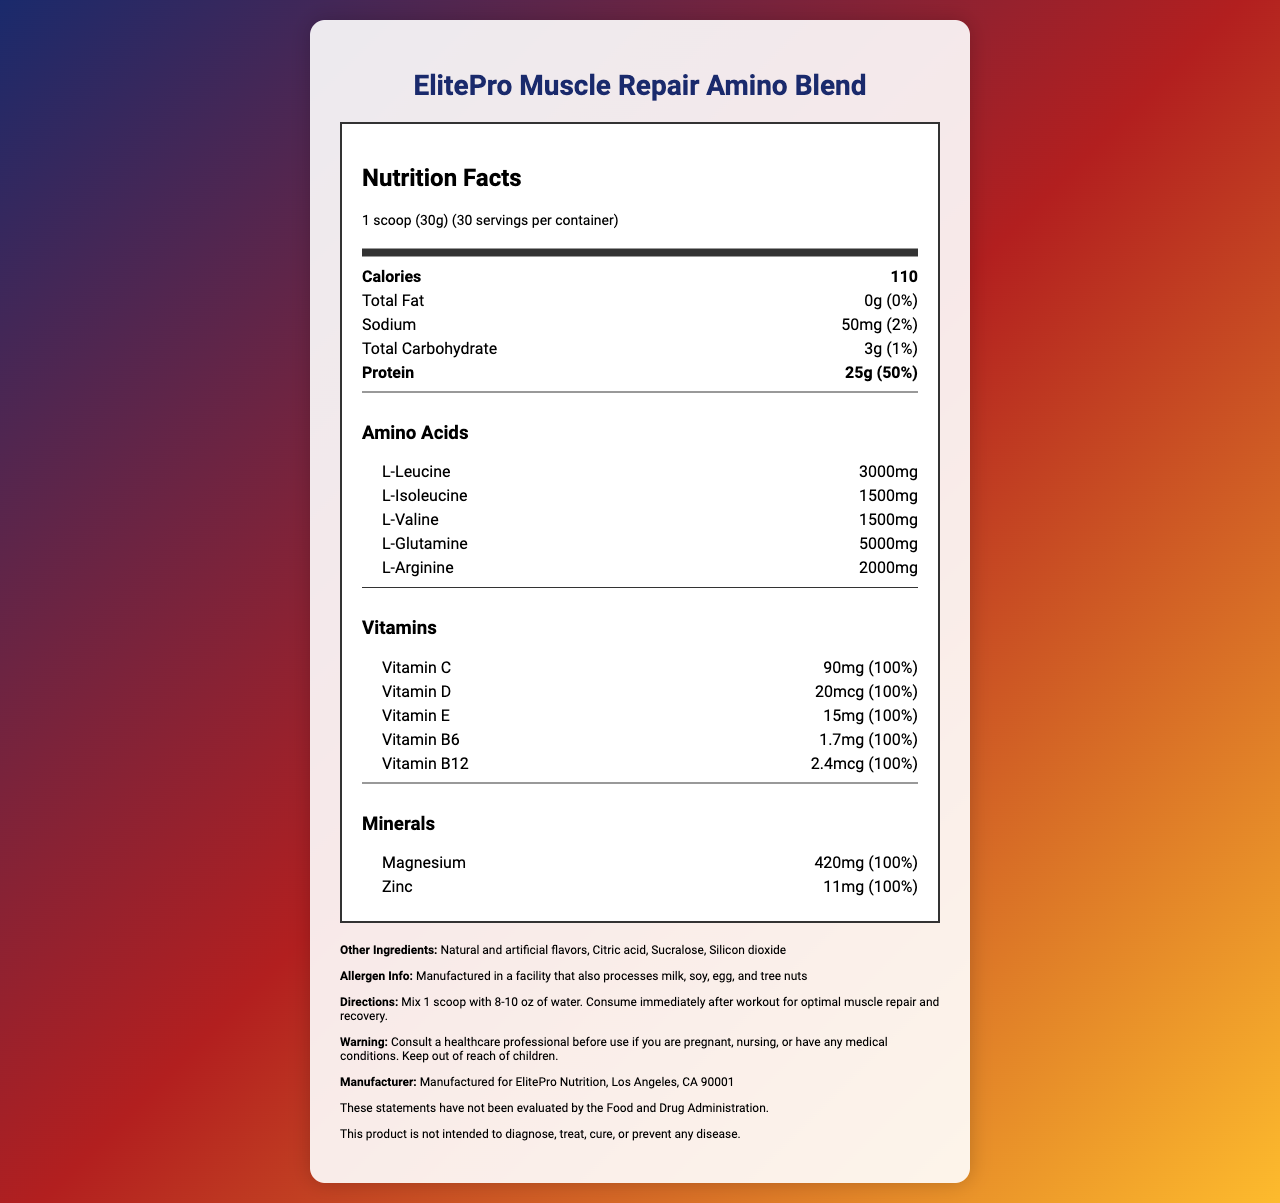what is the serving size? The serving size is specified at the top of the Nutrition Facts label.
Answer: 1 scoop (30g) how many calories are in one serving? The calories amount is listed as 110 in the Nutrition Facts section.
Answer: 110 what is the amount of L-Glutamine per serving? The amount of L-Glutamine is listed under the Amino Acids section as 5000mg.
Answer: 5000mg which vitamins are included and in what amounts? The Vitamins section lists the included vitamins and their amounts.
Answer: Vitamin C (90mg), Vitamin D (20mcg), Vitamin E (15mg), Vitamin B6 (1.7mg), Vitamin B12 (2.4mcg) what percentage of the daily value does the sodium content represent? The sodium daily value percentage is listed as 2%.
Answer: 2% which amino acid is present in the highest amount? L-Glutamine has the highest amount listed at 5000mg.
Answer: L-Glutamine how many grams of protein are present in one serving? The protein amount per serving is specified as 25g.
Answer: 25g what should you do before using this product if you are pregnant or have any medical conditions? The warning statement advises consulting a healthcare professional.
Answer: Consult a healthcare professional how many servings are there per container? The servings per container are listed as 30.
Answer: 30 name one of the other ingredients in the product. The other ingredients section lists Natural and artificial flavors, Citric acid, Sucralose, and Silicon dioxide.
Answer: Natural and artificial flavors (or Citric acid, Sucralose, Silicon dioxide) how should the product be consumed for optimal muscle repair? The directions specify how to mix and consume the product for optimal muscle repair and recovery.
Answer: Mix 1 scoop with 8-10 oz of water and consume immediately after workout which mineral is listed and in what amount? The mineral Magnesium is listed with an amount of 420mg.
Answer: Magnesium (420mg) which of the following is not an amino acid present in the blend? A. L-Leucine B. L-Isoleucine C. L-Carnitine D. L-Arginine The listed amino acids are L-Leucine, L-Isoleucine, L-Valine, L-Glutamine, and L-Arginine. L-Carnitine is not mentioned.
Answer: C. L-Carnitine what is the name of the product? The product name is specified at the top of the document.
Answer: ElitePro Muscle Repair Amino Blend does this product contain any fat? The total fat content is listed as 0g, indicating the product contains no fat.
Answer: No summarize the main idea of the document. The document includes detailed nutritional information, ingredient lists, directions for use, and disclaimers.
Answer: The document provides the nutrition facts and ingredient information for ElitePro Muscle Repair Amino Blend, a post-workout supplement designed to aid muscle repair and recovery by providing a blend of amino acids, vitamins, minerals, and other ingredients. will this product diagnose, treat, cure, or prevent any disease? The disclaimers specifically state that the product is not intended to diagnose, treat, cure, or prevent any disease.
Answer: No what is the exact calorie content from fat in this product? The document does not provide specific information about calories from fat, only the total calories and total fat which is 0g.
Answer: Cannot be determined 